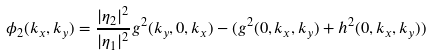Convert formula to latex. <formula><loc_0><loc_0><loc_500><loc_500>\phi _ { 2 } ( k _ { x } , k _ { y } ) = \frac { | \eta _ { 2 } | ^ { 2 } } { | \eta _ { 1 } | ^ { 2 } } g ^ { 2 } ( k _ { y } , 0 , k _ { x } ) - ( g ^ { 2 } ( 0 , k _ { x } , k _ { y } ) + h ^ { 2 } ( 0 , k _ { x } , k _ { y } ) )</formula> 